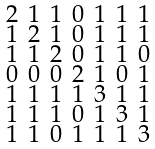Convert formula to latex. <formula><loc_0><loc_0><loc_500><loc_500>\begin{smallmatrix} 2 & 1 & 1 & 0 & 1 & 1 & 1 \\ 1 & 2 & 1 & 0 & 1 & 1 & 1 \\ 1 & 1 & 2 & 0 & 1 & 1 & 0 \\ 0 & 0 & 0 & 2 & 1 & 0 & 1 \\ 1 & 1 & 1 & 1 & 3 & 1 & 1 \\ 1 & 1 & 1 & 0 & 1 & 3 & 1 \\ 1 & 1 & 0 & 1 & 1 & 1 & 3 \end{smallmatrix}</formula> 